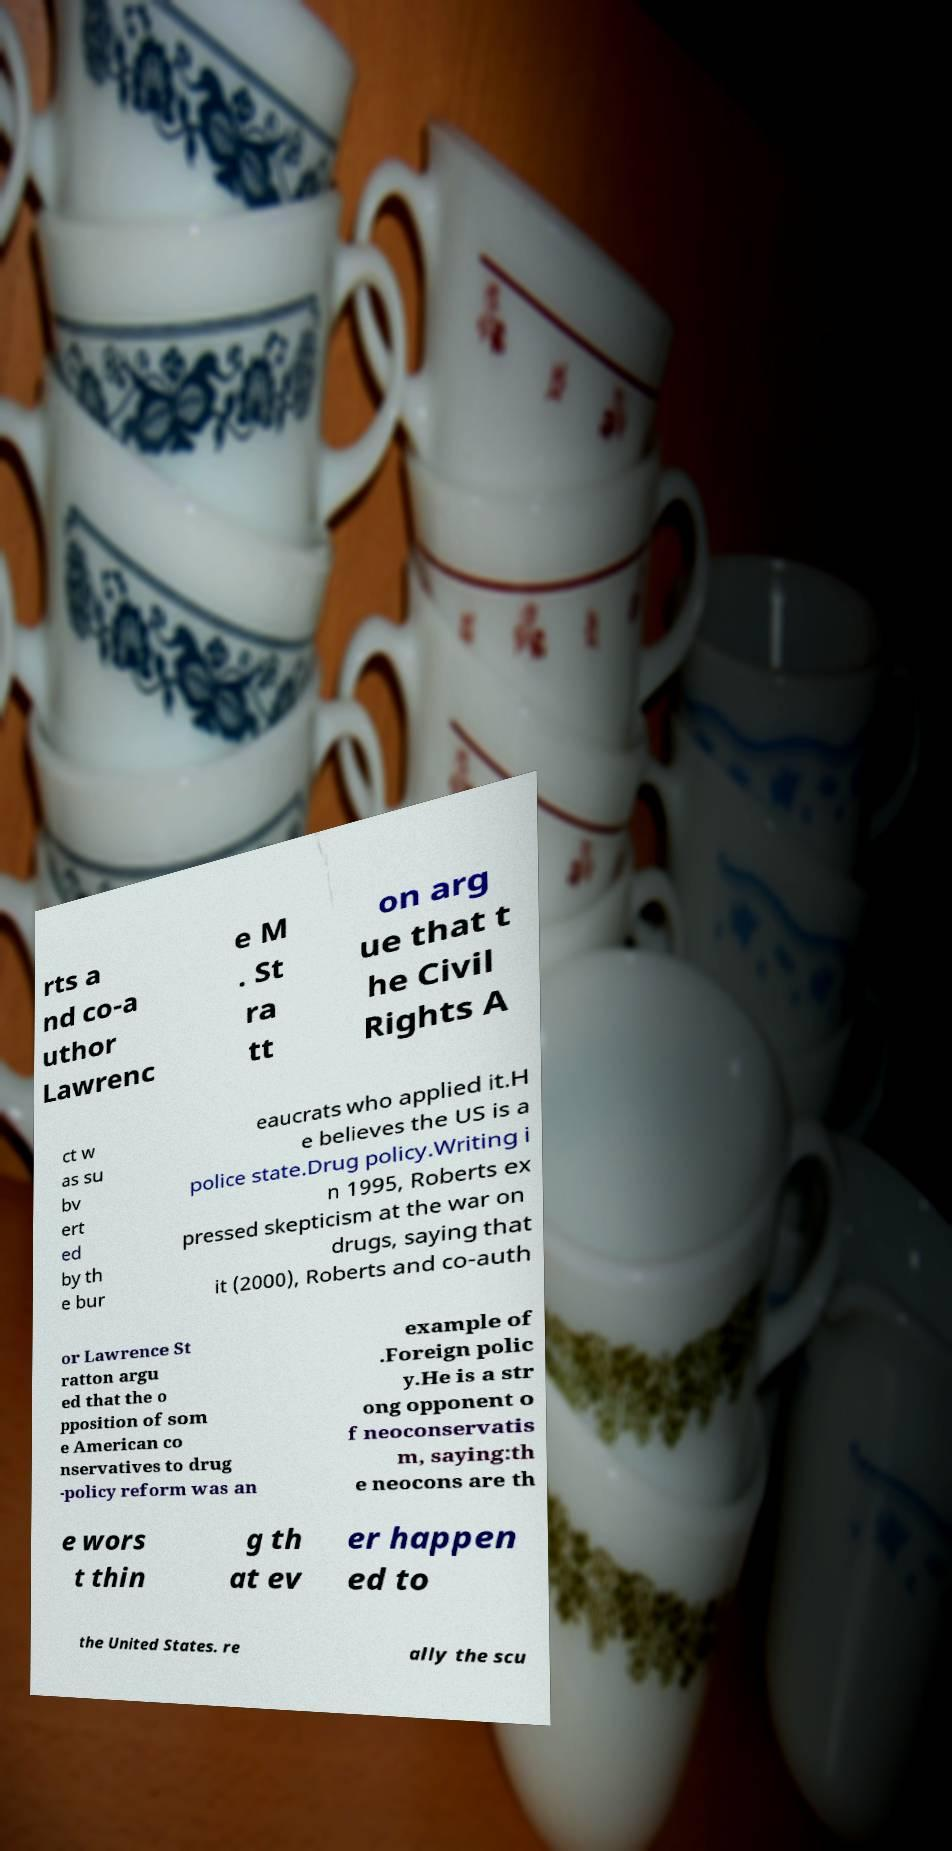For documentation purposes, I need the text within this image transcribed. Could you provide that? rts a nd co-a uthor Lawrenc e M . St ra tt on arg ue that t he Civil Rights A ct w as su bv ert ed by th e bur eaucrats who applied it.H e believes the US is a police state.Drug policy.Writing i n 1995, Roberts ex pressed skepticism at the war on drugs, saying that it (2000), Roberts and co-auth or Lawrence St ratton argu ed that the o pposition of som e American co nservatives to drug -policy reform was an example of .Foreign polic y.He is a str ong opponent o f neoconservatis m, saying:th e neocons are th e wors t thin g th at ev er happen ed to the United States. re ally the scu 